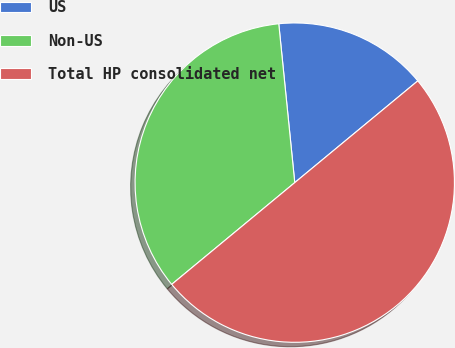<chart> <loc_0><loc_0><loc_500><loc_500><pie_chart><fcel>US<fcel>Non-US<fcel>Total HP consolidated net<nl><fcel>15.6%<fcel>34.4%<fcel>50.0%<nl></chart> 